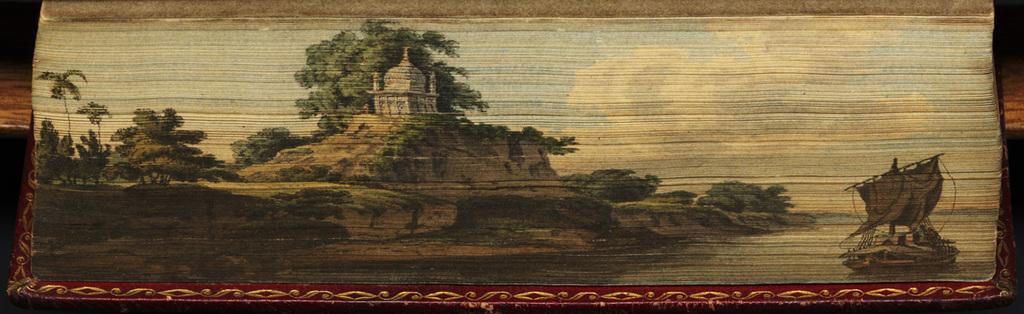What is depicted on the paper in the image? The paper in the image contains a depiction of water, a boat, trees, ancient architecture, and a sky with clouds. Can you describe the scene depicted on the paper? The scene on the paper depicts a body of water with a boat, trees, ancient architecture, and a sky with clouds. What type of architecture is depicted on the paper? The paper contains a depiction of ancient architecture. How many swings are present in the image? There are no swings present in the image; the image features a paper with various depictions. What type of cent is shown interacting with the ancient architecture on the paper? There is no cent depicted in the image; the paper contains a depiction of ancient architecture without any interaction from a cent. 